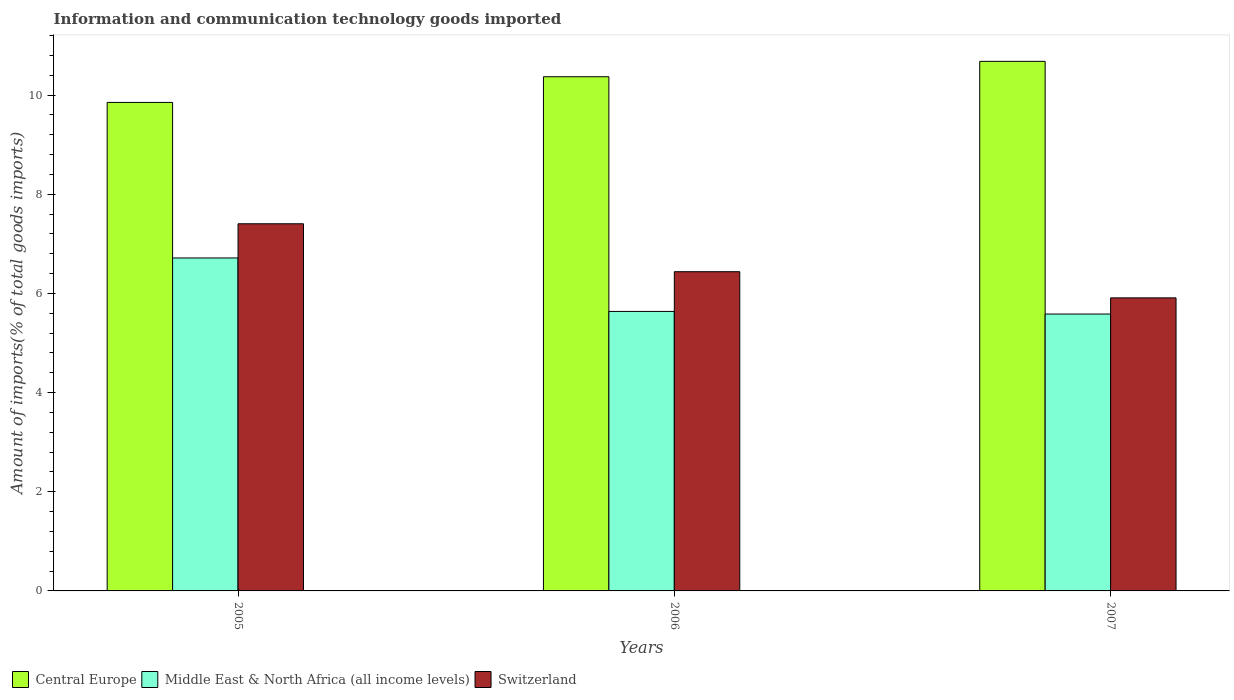How many different coloured bars are there?
Give a very brief answer. 3. How many groups of bars are there?
Keep it short and to the point. 3. Are the number of bars per tick equal to the number of legend labels?
Your response must be concise. Yes. How many bars are there on the 3rd tick from the left?
Your answer should be very brief. 3. How many bars are there on the 3rd tick from the right?
Provide a succinct answer. 3. What is the amount of goods imported in Central Europe in 2007?
Offer a very short reply. 10.68. Across all years, what is the maximum amount of goods imported in Switzerland?
Make the answer very short. 7.41. Across all years, what is the minimum amount of goods imported in Switzerland?
Keep it short and to the point. 5.91. In which year was the amount of goods imported in Middle East & North Africa (all income levels) maximum?
Offer a terse response. 2005. What is the total amount of goods imported in Switzerland in the graph?
Your response must be concise. 19.76. What is the difference between the amount of goods imported in Central Europe in 2005 and that in 2006?
Your response must be concise. -0.52. What is the difference between the amount of goods imported in Middle East & North Africa (all income levels) in 2005 and the amount of goods imported in Switzerland in 2006?
Offer a terse response. 0.28. What is the average amount of goods imported in Middle East & North Africa (all income levels) per year?
Your answer should be very brief. 5.98. In the year 2007, what is the difference between the amount of goods imported in Middle East & North Africa (all income levels) and amount of goods imported in Switzerland?
Provide a succinct answer. -0.33. What is the ratio of the amount of goods imported in Central Europe in 2006 to that in 2007?
Give a very brief answer. 0.97. Is the amount of goods imported in Central Europe in 2005 less than that in 2007?
Your answer should be very brief. Yes. What is the difference between the highest and the second highest amount of goods imported in Central Europe?
Offer a very short reply. 0.31. What is the difference between the highest and the lowest amount of goods imported in Central Europe?
Your answer should be compact. 0.83. In how many years, is the amount of goods imported in Central Europe greater than the average amount of goods imported in Central Europe taken over all years?
Your answer should be compact. 2. What does the 1st bar from the left in 2006 represents?
Give a very brief answer. Central Europe. What does the 1st bar from the right in 2007 represents?
Provide a succinct answer. Switzerland. Is it the case that in every year, the sum of the amount of goods imported in Switzerland and amount of goods imported in Middle East & North Africa (all income levels) is greater than the amount of goods imported in Central Europe?
Provide a succinct answer. Yes. How many years are there in the graph?
Ensure brevity in your answer.  3. Does the graph contain grids?
Provide a succinct answer. No. Where does the legend appear in the graph?
Ensure brevity in your answer.  Bottom left. How are the legend labels stacked?
Keep it short and to the point. Horizontal. What is the title of the graph?
Offer a very short reply. Information and communication technology goods imported. Does "Belarus" appear as one of the legend labels in the graph?
Keep it short and to the point. No. What is the label or title of the Y-axis?
Give a very brief answer. Amount of imports(% of total goods imports). What is the Amount of imports(% of total goods imports) of Central Europe in 2005?
Offer a terse response. 9.85. What is the Amount of imports(% of total goods imports) of Middle East & North Africa (all income levels) in 2005?
Provide a succinct answer. 6.72. What is the Amount of imports(% of total goods imports) of Switzerland in 2005?
Provide a short and direct response. 7.41. What is the Amount of imports(% of total goods imports) in Central Europe in 2006?
Offer a very short reply. 10.37. What is the Amount of imports(% of total goods imports) of Middle East & North Africa (all income levels) in 2006?
Provide a succinct answer. 5.64. What is the Amount of imports(% of total goods imports) in Switzerland in 2006?
Your answer should be compact. 6.44. What is the Amount of imports(% of total goods imports) in Central Europe in 2007?
Ensure brevity in your answer.  10.68. What is the Amount of imports(% of total goods imports) in Middle East & North Africa (all income levels) in 2007?
Give a very brief answer. 5.58. What is the Amount of imports(% of total goods imports) in Switzerland in 2007?
Your answer should be very brief. 5.91. Across all years, what is the maximum Amount of imports(% of total goods imports) of Central Europe?
Provide a short and direct response. 10.68. Across all years, what is the maximum Amount of imports(% of total goods imports) of Middle East & North Africa (all income levels)?
Keep it short and to the point. 6.72. Across all years, what is the maximum Amount of imports(% of total goods imports) of Switzerland?
Provide a succinct answer. 7.41. Across all years, what is the minimum Amount of imports(% of total goods imports) in Central Europe?
Ensure brevity in your answer.  9.85. Across all years, what is the minimum Amount of imports(% of total goods imports) of Middle East & North Africa (all income levels)?
Keep it short and to the point. 5.58. Across all years, what is the minimum Amount of imports(% of total goods imports) of Switzerland?
Offer a very short reply. 5.91. What is the total Amount of imports(% of total goods imports) in Central Europe in the graph?
Provide a succinct answer. 30.91. What is the total Amount of imports(% of total goods imports) in Middle East & North Africa (all income levels) in the graph?
Your response must be concise. 17.94. What is the total Amount of imports(% of total goods imports) of Switzerland in the graph?
Your answer should be compact. 19.76. What is the difference between the Amount of imports(% of total goods imports) in Central Europe in 2005 and that in 2006?
Give a very brief answer. -0.52. What is the difference between the Amount of imports(% of total goods imports) in Middle East & North Africa (all income levels) in 2005 and that in 2006?
Your response must be concise. 1.08. What is the difference between the Amount of imports(% of total goods imports) of Central Europe in 2005 and that in 2007?
Offer a terse response. -0.83. What is the difference between the Amount of imports(% of total goods imports) of Middle East & North Africa (all income levels) in 2005 and that in 2007?
Make the answer very short. 1.13. What is the difference between the Amount of imports(% of total goods imports) of Switzerland in 2005 and that in 2007?
Provide a short and direct response. 1.49. What is the difference between the Amount of imports(% of total goods imports) in Central Europe in 2006 and that in 2007?
Offer a terse response. -0.31. What is the difference between the Amount of imports(% of total goods imports) of Middle East & North Africa (all income levels) in 2006 and that in 2007?
Offer a very short reply. 0.05. What is the difference between the Amount of imports(% of total goods imports) of Switzerland in 2006 and that in 2007?
Offer a terse response. 0.53. What is the difference between the Amount of imports(% of total goods imports) of Central Europe in 2005 and the Amount of imports(% of total goods imports) of Middle East & North Africa (all income levels) in 2006?
Ensure brevity in your answer.  4.22. What is the difference between the Amount of imports(% of total goods imports) of Central Europe in 2005 and the Amount of imports(% of total goods imports) of Switzerland in 2006?
Your answer should be very brief. 3.41. What is the difference between the Amount of imports(% of total goods imports) in Middle East & North Africa (all income levels) in 2005 and the Amount of imports(% of total goods imports) in Switzerland in 2006?
Provide a succinct answer. 0.28. What is the difference between the Amount of imports(% of total goods imports) in Central Europe in 2005 and the Amount of imports(% of total goods imports) in Middle East & North Africa (all income levels) in 2007?
Offer a very short reply. 4.27. What is the difference between the Amount of imports(% of total goods imports) in Central Europe in 2005 and the Amount of imports(% of total goods imports) in Switzerland in 2007?
Provide a succinct answer. 3.94. What is the difference between the Amount of imports(% of total goods imports) in Middle East & North Africa (all income levels) in 2005 and the Amount of imports(% of total goods imports) in Switzerland in 2007?
Offer a very short reply. 0.8. What is the difference between the Amount of imports(% of total goods imports) in Central Europe in 2006 and the Amount of imports(% of total goods imports) in Middle East & North Africa (all income levels) in 2007?
Your response must be concise. 4.79. What is the difference between the Amount of imports(% of total goods imports) of Central Europe in 2006 and the Amount of imports(% of total goods imports) of Switzerland in 2007?
Keep it short and to the point. 4.46. What is the difference between the Amount of imports(% of total goods imports) in Middle East & North Africa (all income levels) in 2006 and the Amount of imports(% of total goods imports) in Switzerland in 2007?
Your answer should be compact. -0.27. What is the average Amount of imports(% of total goods imports) of Central Europe per year?
Your response must be concise. 10.3. What is the average Amount of imports(% of total goods imports) in Middle East & North Africa (all income levels) per year?
Your answer should be very brief. 5.98. What is the average Amount of imports(% of total goods imports) in Switzerland per year?
Keep it short and to the point. 6.59. In the year 2005, what is the difference between the Amount of imports(% of total goods imports) of Central Europe and Amount of imports(% of total goods imports) of Middle East & North Africa (all income levels)?
Offer a terse response. 3.14. In the year 2005, what is the difference between the Amount of imports(% of total goods imports) in Central Europe and Amount of imports(% of total goods imports) in Switzerland?
Your answer should be compact. 2.45. In the year 2005, what is the difference between the Amount of imports(% of total goods imports) of Middle East & North Africa (all income levels) and Amount of imports(% of total goods imports) of Switzerland?
Give a very brief answer. -0.69. In the year 2006, what is the difference between the Amount of imports(% of total goods imports) in Central Europe and Amount of imports(% of total goods imports) in Middle East & North Africa (all income levels)?
Give a very brief answer. 4.73. In the year 2006, what is the difference between the Amount of imports(% of total goods imports) in Central Europe and Amount of imports(% of total goods imports) in Switzerland?
Offer a very short reply. 3.93. In the year 2006, what is the difference between the Amount of imports(% of total goods imports) in Middle East & North Africa (all income levels) and Amount of imports(% of total goods imports) in Switzerland?
Keep it short and to the point. -0.8. In the year 2007, what is the difference between the Amount of imports(% of total goods imports) of Central Europe and Amount of imports(% of total goods imports) of Middle East & North Africa (all income levels)?
Your answer should be compact. 5.1. In the year 2007, what is the difference between the Amount of imports(% of total goods imports) of Central Europe and Amount of imports(% of total goods imports) of Switzerland?
Provide a short and direct response. 4.77. In the year 2007, what is the difference between the Amount of imports(% of total goods imports) in Middle East & North Africa (all income levels) and Amount of imports(% of total goods imports) in Switzerland?
Ensure brevity in your answer.  -0.33. What is the ratio of the Amount of imports(% of total goods imports) in Middle East & North Africa (all income levels) in 2005 to that in 2006?
Provide a succinct answer. 1.19. What is the ratio of the Amount of imports(% of total goods imports) in Switzerland in 2005 to that in 2006?
Your response must be concise. 1.15. What is the ratio of the Amount of imports(% of total goods imports) in Central Europe in 2005 to that in 2007?
Offer a terse response. 0.92. What is the ratio of the Amount of imports(% of total goods imports) of Middle East & North Africa (all income levels) in 2005 to that in 2007?
Provide a succinct answer. 1.2. What is the ratio of the Amount of imports(% of total goods imports) in Switzerland in 2005 to that in 2007?
Keep it short and to the point. 1.25. What is the ratio of the Amount of imports(% of total goods imports) of Middle East & North Africa (all income levels) in 2006 to that in 2007?
Make the answer very short. 1.01. What is the ratio of the Amount of imports(% of total goods imports) of Switzerland in 2006 to that in 2007?
Give a very brief answer. 1.09. What is the difference between the highest and the second highest Amount of imports(% of total goods imports) in Central Europe?
Offer a very short reply. 0.31. What is the difference between the highest and the second highest Amount of imports(% of total goods imports) of Middle East & North Africa (all income levels)?
Offer a terse response. 1.08. What is the difference between the highest and the lowest Amount of imports(% of total goods imports) in Central Europe?
Give a very brief answer. 0.83. What is the difference between the highest and the lowest Amount of imports(% of total goods imports) in Middle East & North Africa (all income levels)?
Offer a terse response. 1.13. What is the difference between the highest and the lowest Amount of imports(% of total goods imports) in Switzerland?
Offer a very short reply. 1.49. 